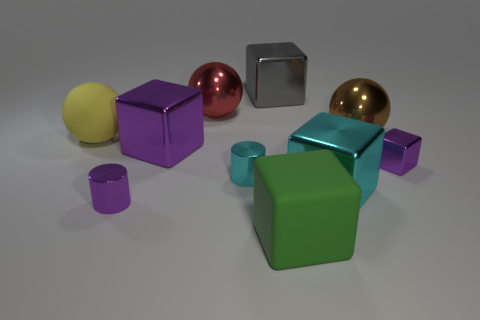Subtract all green blocks. How many blocks are left? 4 Subtract all large matte cubes. How many cubes are left? 4 Subtract all brown cubes. Subtract all red cylinders. How many cubes are left? 5 Subtract all spheres. How many objects are left? 7 Subtract all big gray things. Subtract all large green objects. How many objects are left? 8 Add 7 red balls. How many red balls are left? 8 Add 6 small brown metal objects. How many small brown metal objects exist? 6 Subtract 0 green cylinders. How many objects are left? 10 